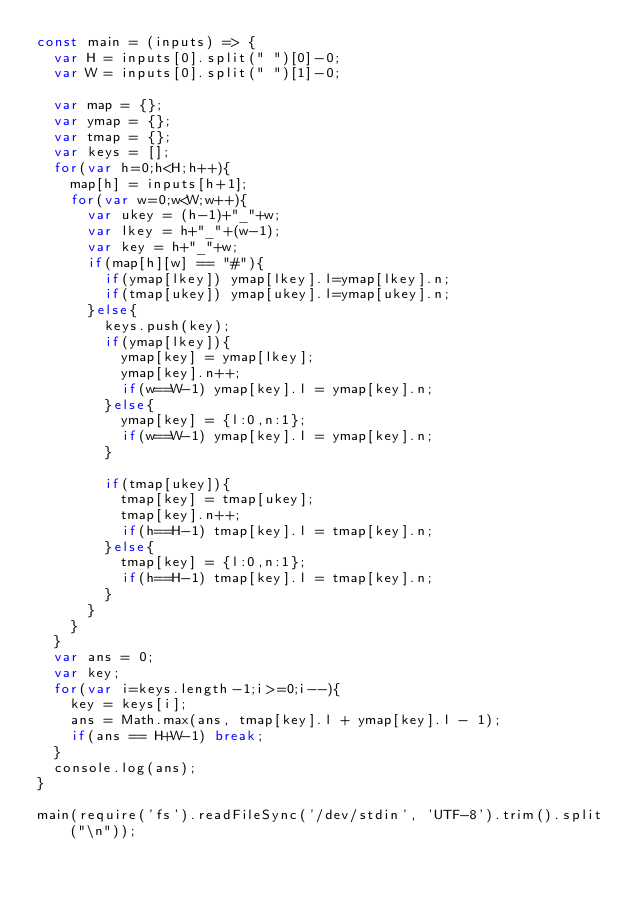Convert code to text. <code><loc_0><loc_0><loc_500><loc_500><_JavaScript_>const main = (inputs) => {
  var H = inputs[0].split(" ")[0]-0;
  var W = inputs[0].split(" ")[1]-0;

  var map = {};
  var ymap = {};
  var tmap = {};
  var keys = [];
  for(var h=0;h<H;h++){
    map[h] = inputs[h+1];
    for(var w=0;w<W;w++){
      var ukey = (h-1)+"_"+w;
      var lkey = h+"_"+(w-1);
      var key = h+"_"+w;
      if(map[h][w] == "#"){
        if(ymap[lkey]) ymap[lkey].l=ymap[lkey].n;
        if(tmap[ukey]) ymap[ukey].l=ymap[ukey].n;
      }else{
        keys.push(key);
        if(ymap[lkey]){
          ymap[key] = ymap[lkey];
          ymap[key].n++;
          if(w==W-1) ymap[key].l = ymap[key].n;
        }else{
          ymap[key] = {l:0,n:1};
          if(w==W-1) ymap[key].l = ymap[key].n;
        }

        if(tmap[ukey]){
          tmap[key] = tmap[ukey];
          tmap[key].n++;
          if(h==H-1) tmap[key].l = tmap[key].n;
        }else{
          tmap[key] = {l:0,n:1};
          if(h==H-1) tmap[key].l = tmap[key].n;
        }
      }
    }
  }
  var ans = 0;
  var key;
  for(var i=keys.length-1;i>=0;i--){
    key = keys[i];
    ans = Math.max(ans, tmap[key].l + ymap[key].l - 1);
    if(ans == H+W-1) break;
  }
  console.log(ans);
}

main(require('fs').readFileSync('/dev/stdin', 'UTF-8').trim().split("\n"));
</code> 